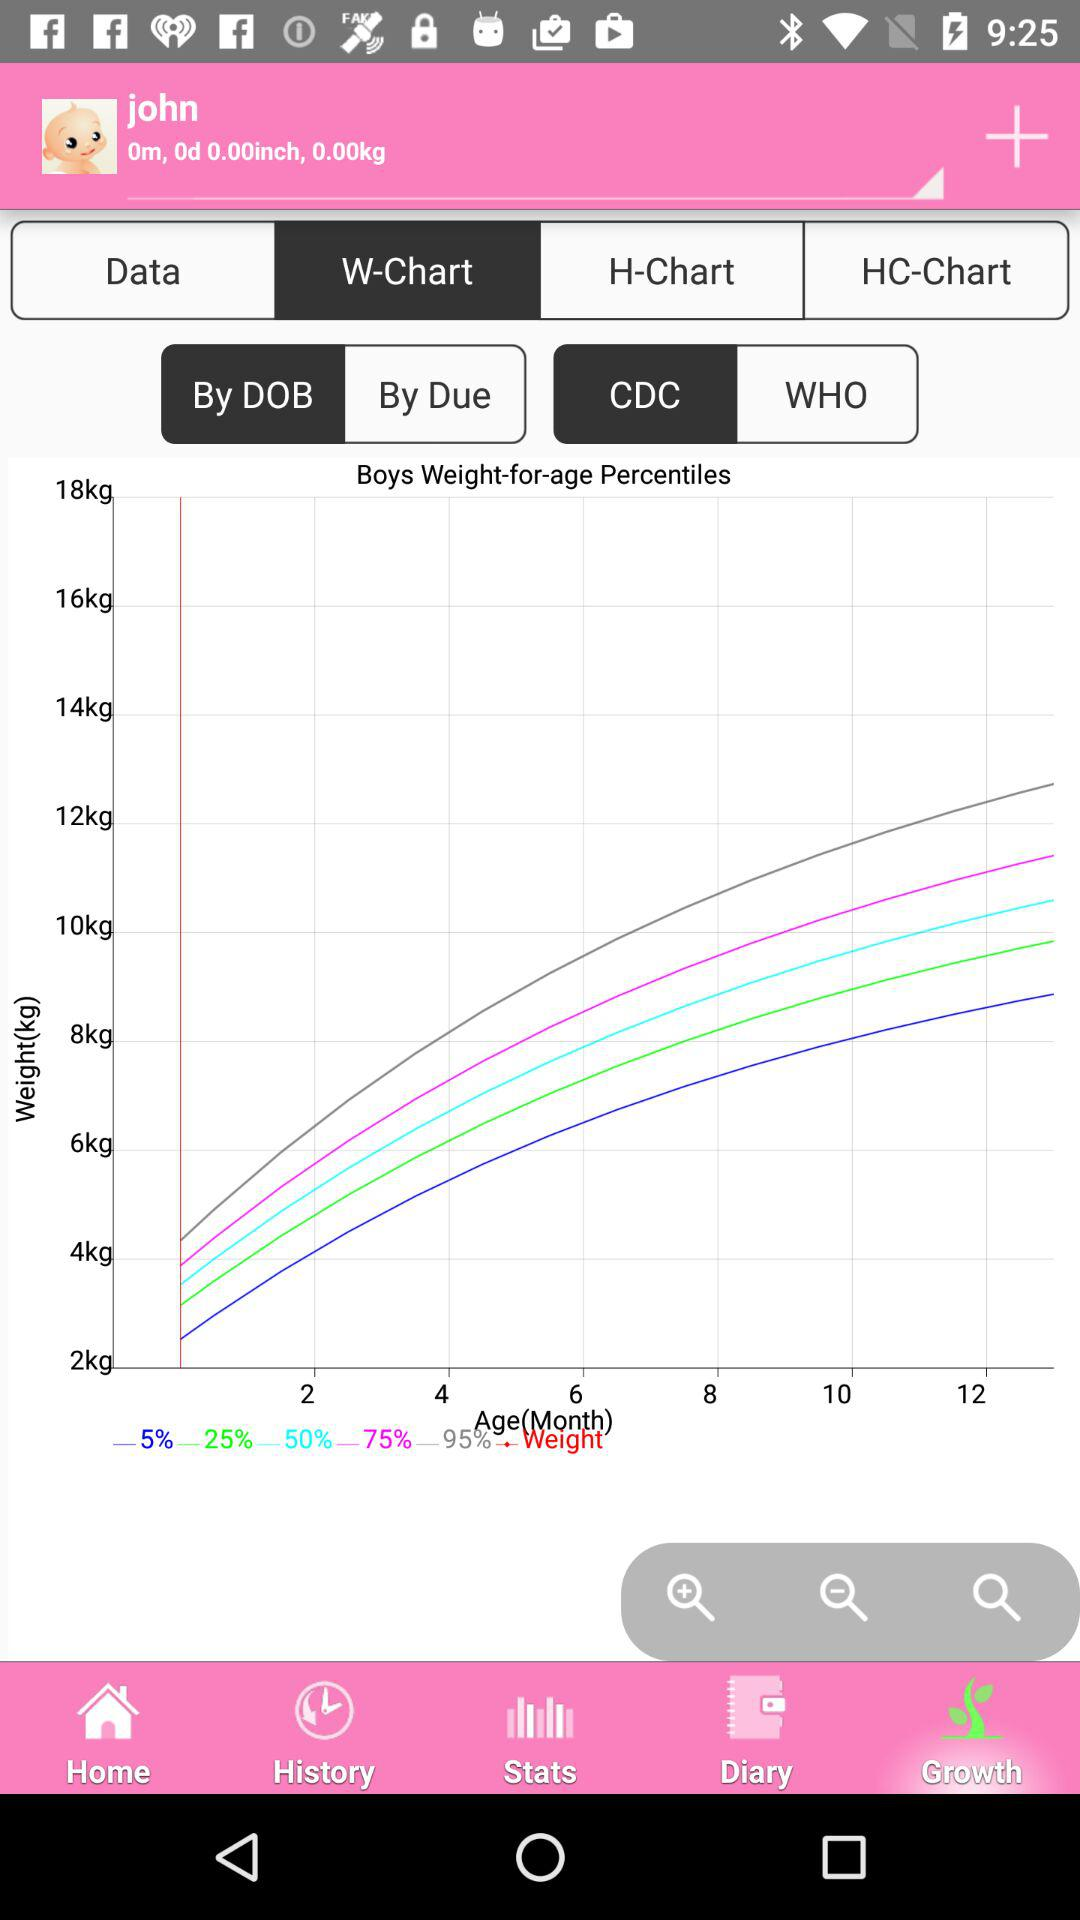How many different percentiles are shown on the graph?
Answer the question using a single word or phrase. 5 